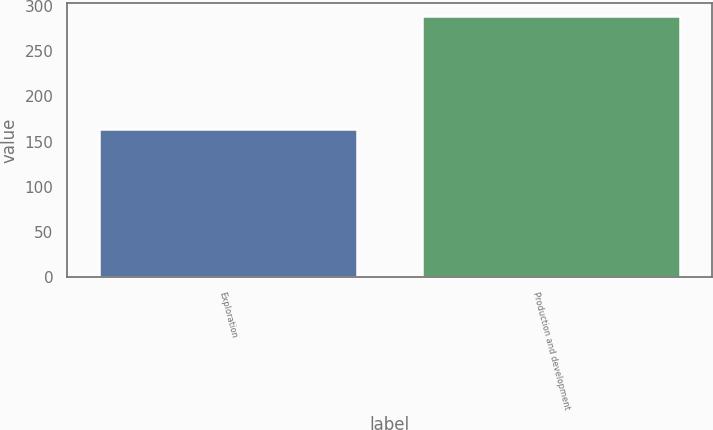<chart> <loc_0><loc_0><loc_500><loc_500><bar_chart><fcel>Exploration<fcel>Production and development<nl><fcel>164<fcel>289<nl></chart> 